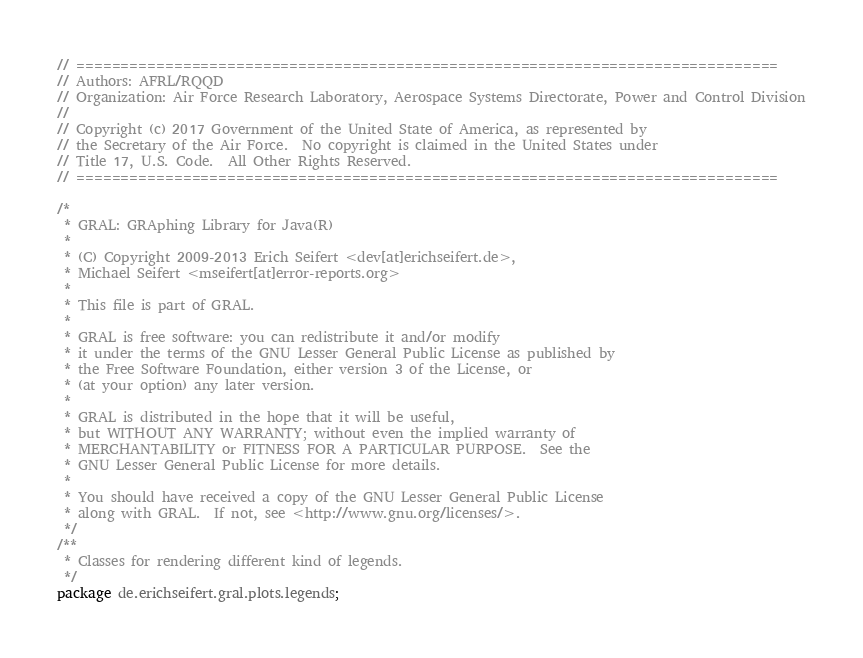Convert code to text. <code><loc_0><loc_0><loc_500><loc_500><_Java_>// ===============================================================================
// Authors: AFRL/RQQD
// Organization: Air Force Research Laboratory, Aerospace Systems Directorate, Power and Control Division
// 
// Copyright (c) 2017 Government of the United State of America, as represented by
// the Secretary of the Air Force.  No copyright is claimed in the United States under
// Title 17, U.S. Code.  All Other Rights Reserved.
// ===============================================================================

/*
 * GRAL: GRAphing Library for Java(R)
 *
 * (C) Copyright 2009-2013 Erich Seifert <dev[at]erichseifert.de>,
 * Michael Seifert <mseifert[at]error-reports.org>
 *
 * This file is part of GRAL.
 *
 * GRAL is free software: you can redistribute it and/or modify
 * it under the terms of the GNU Lesser General Public License as published by
 * the Free Software Foundation, either version 3 of the License, or
 * (at your option) any later version.
 *
 * GRAL is distributed in the hope that it will be useful,
 * but WITHOUT ANY WARRANTY; without even the implied warranty of
 * MERCHANTABILITY or FITNESS FOR A PARTICULAR PURPOSE.  See the
 * GNU Lesser General Public License for more details.
 *
 * You should have received a copy of the GNU Lesser General Public License
 * along with GRAL.  If not, see <http://www.gnu.org/licenses/>.
 */
/**
 * Classes for rendering different kind of legends.
 */
package de.erichseifert.gral.plots.legends;
</code> 